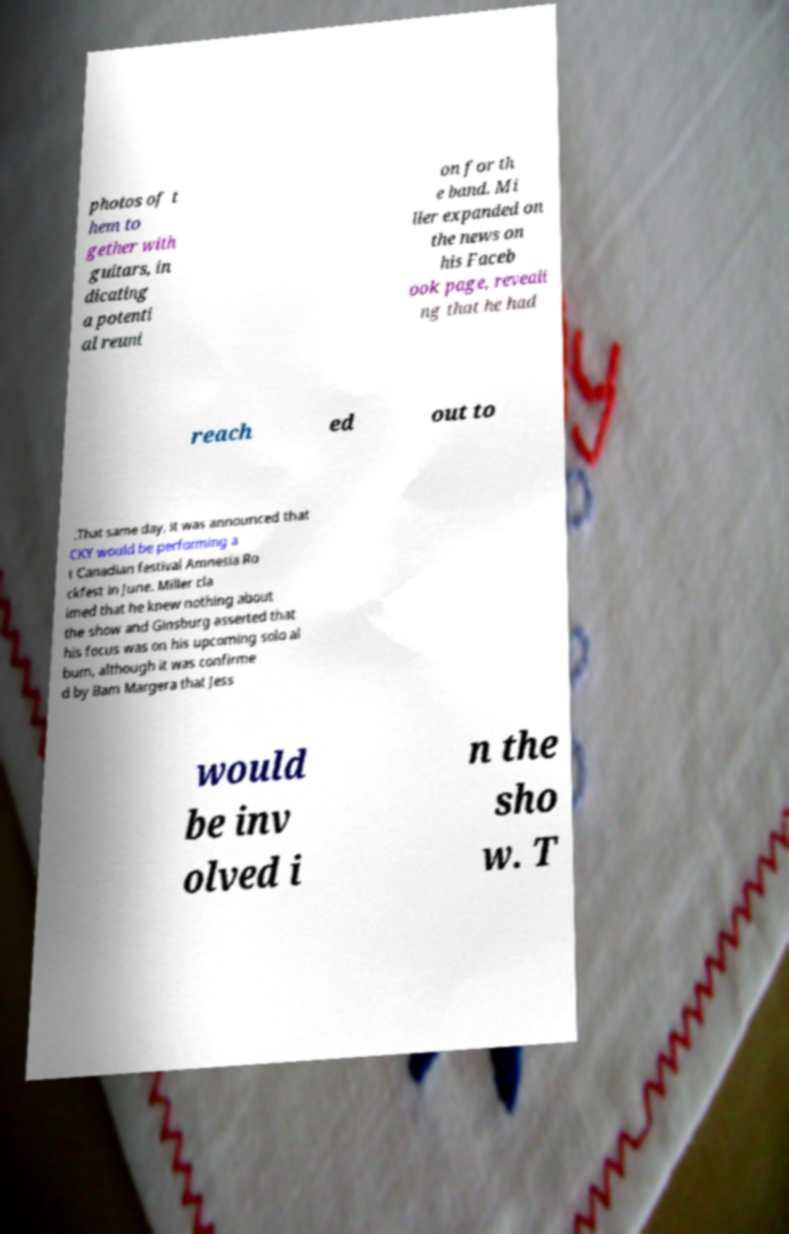Could you extract and type out the text from this image? photos of t hem to gether with guitars, in dicating a potenti al reuni on for th e band. Mi ller expanded on the news on his Faceb ook page, reveali ng that he had reach ed out to .That same day, it was announced that CKY would be performing a t Canadian festival Amnesia Ro ckfest in June. Miller cla imed that he knew nothing about the show and Ginsburg asserted that his focus was on his upcoming solo al bum, although it was confirme d by Bam Margera that Jess would be inv olved i n the sho w. T 